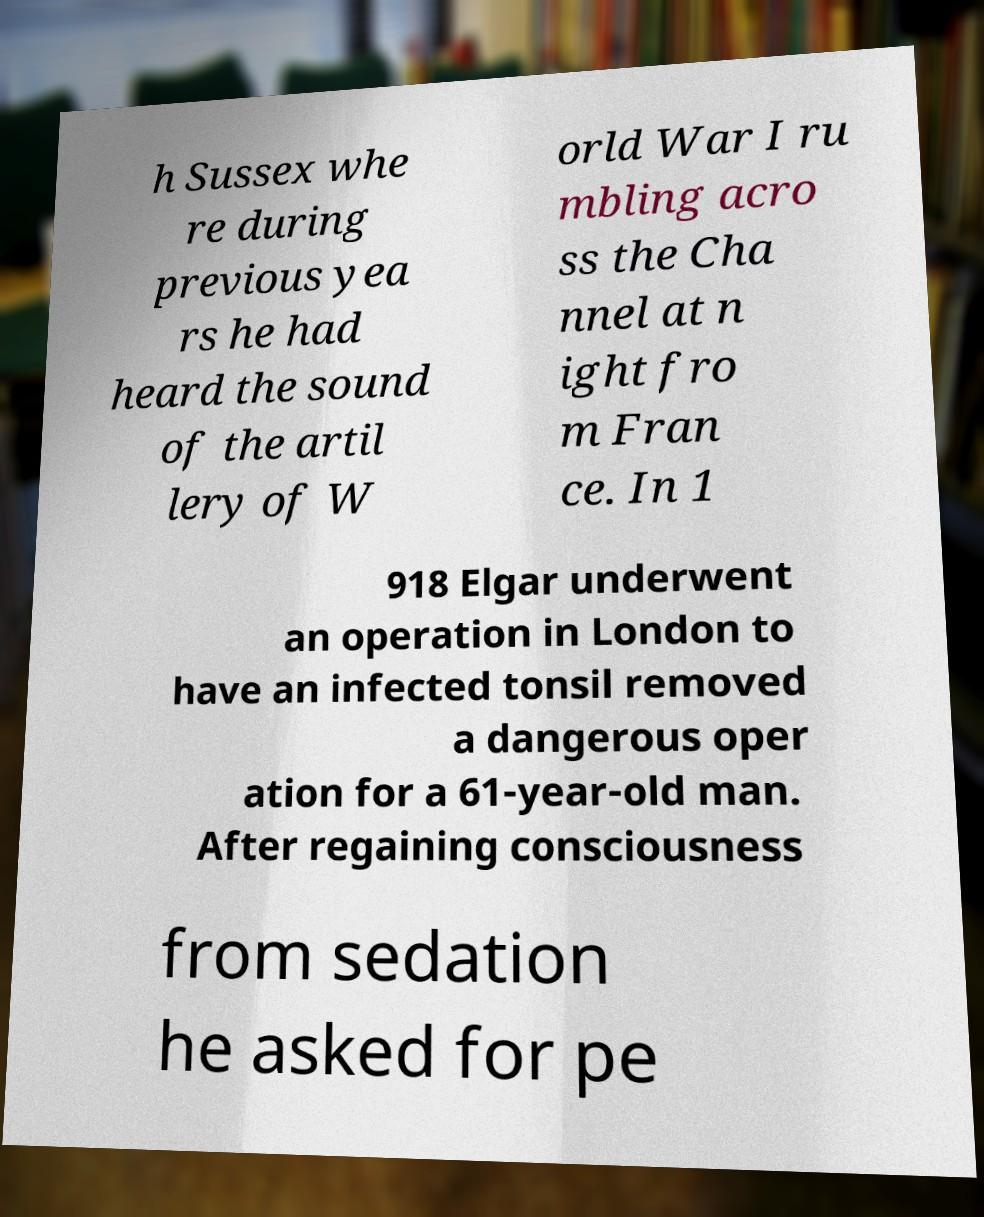For documentation purposes, I need the text within this image transcribed. Could you provide that? h Sussex whe re during previous yea rs he had heard the sound of the artil lery of W orld War I ru mbling acro ss the Cha nnel at n ight fro m Fran ce. In 1 918 Elgar underwent an operation in London to have an infected tonsil removed a dangerous oper ation for a 61-year-old man. After regaining consciousness from sedation he asked for pe 